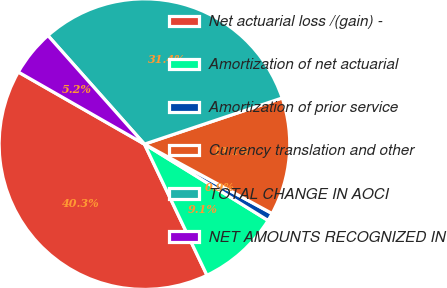Convert chart. <chart><loc_0><loc_0><loc_500><loc_500><pie_chart><fcel>Net actuarial loss /(gain) -<fcel>Amortization of net actuarial<fcel>Amortization of prior service<fcel>Currency translation and other<fcel>TOTAL CHANGE IN AOCI<fcel>NET AMOUNTS RECOGNIZED IN<nl><fcel>40.35%<fcel>9.12%<fcel>0.88%<fcel>13.07%<fcel>31.42%<fcel>5.17%<nl></chart> 